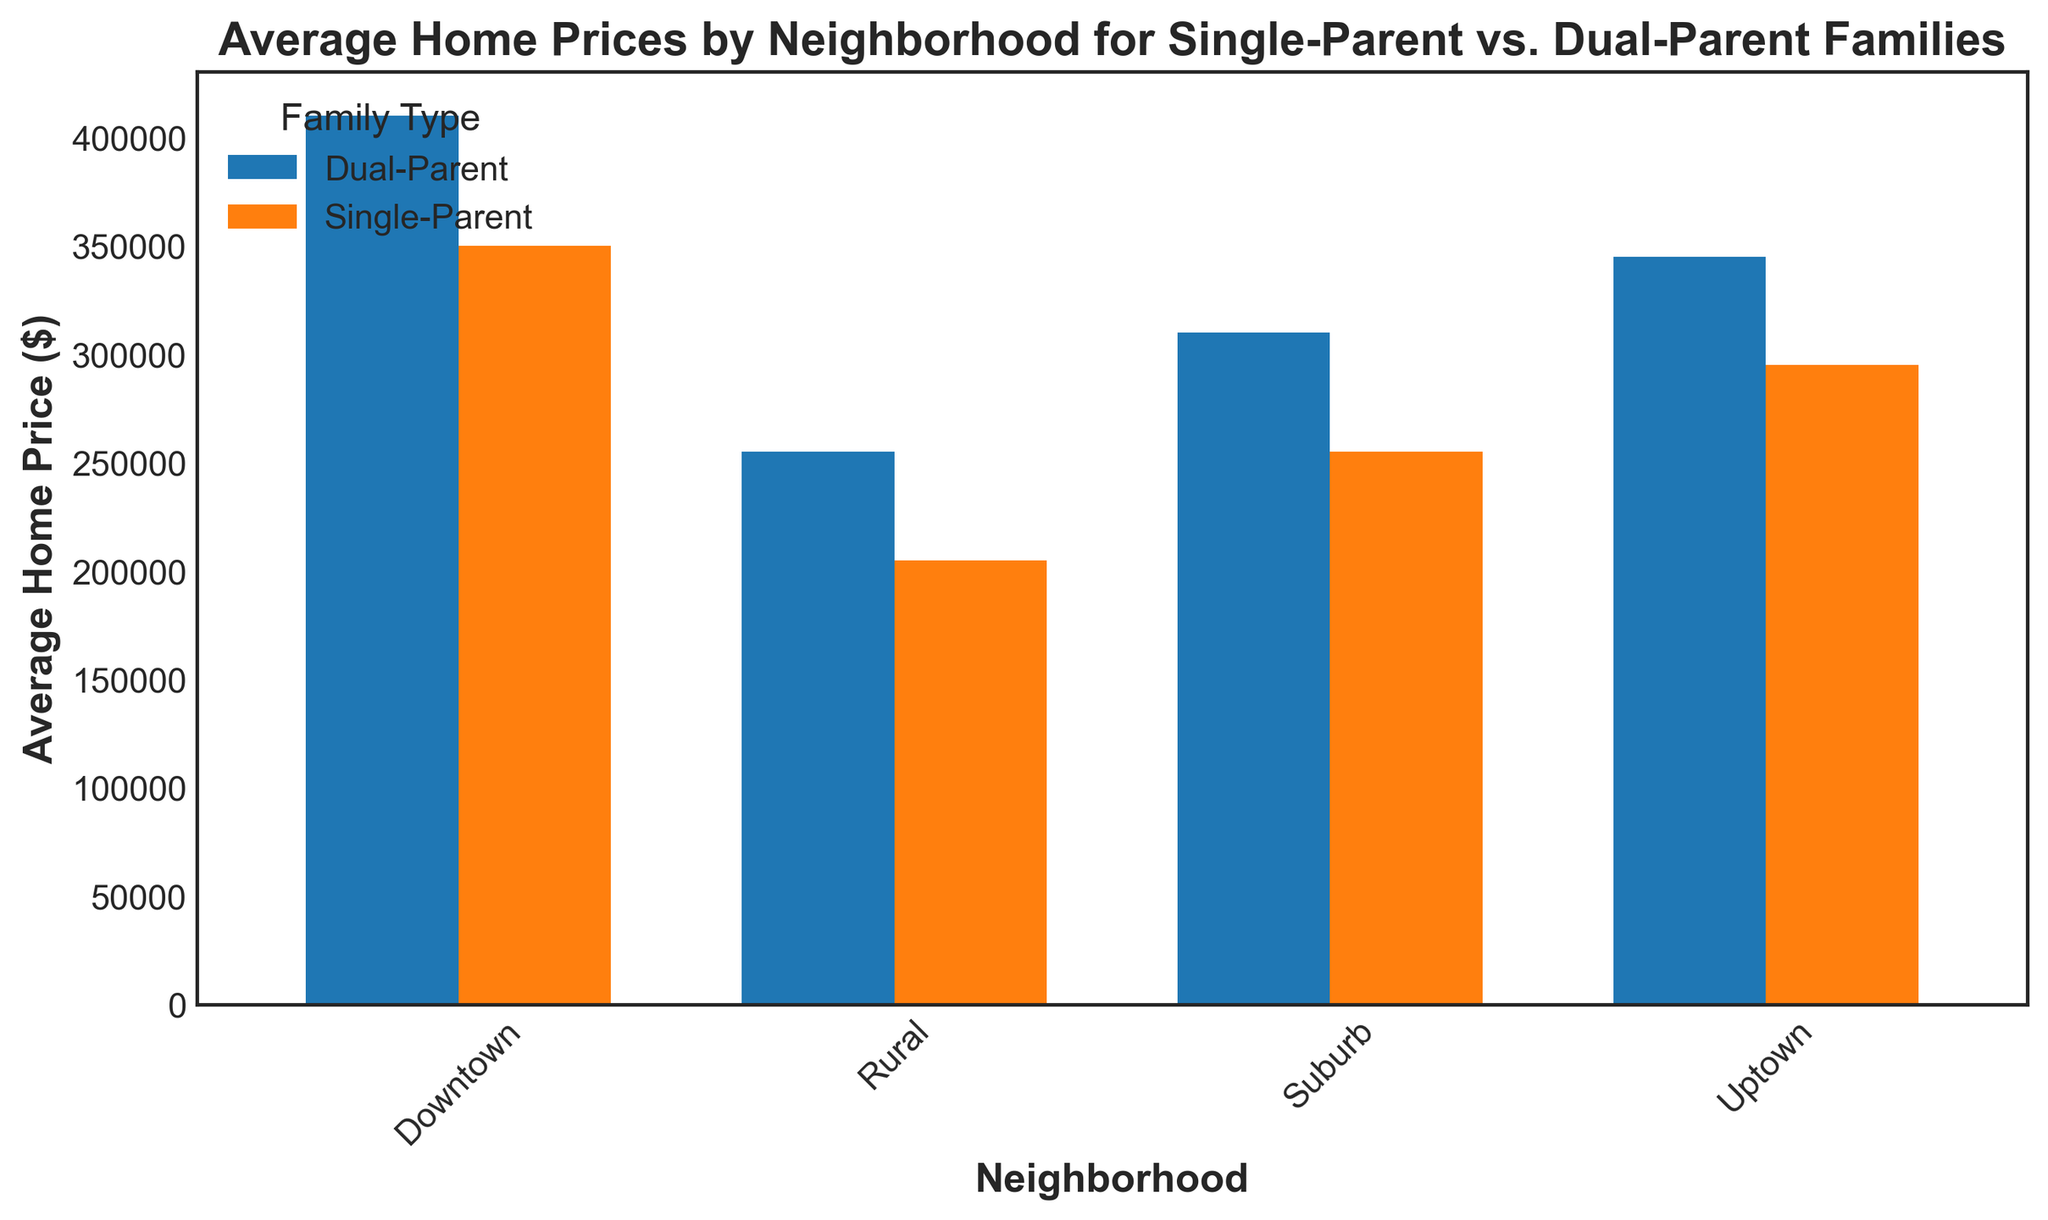What's the average home price for single-parent families in the Downtown neighborhood? Visually, you can observe the bars for single-parent families in the Downtown neighborhood. The average is given by the height of the blue bar representing single-parent families. So the average home price for single-parent families in Downtown is $350,000.
Answer: $350,000 Which neighborhood has the highest average home price for dual-parent families? Examine the orange bars across all neighborhoods, which represent the average home prices for dual-parent families. Identify the tallest orange bar. It is in the Downtown neighborhood.
Answer: Downtown What is the price difference between single-parent and dual-parent families in the Uptown neighborhood? Look at the blue bar for single-parent families and the orange bar for dual-parent families in the Uptown neighborhood. The blue bar (single-parent) is at $295,000, and the orange bar (dual-parent) is at $345,000. The difference is $345,000 - $295,000 = $50,000.
Answer: $50,000 Which family type has a higher average home price in the Suburb neighborhood? Compare the heights of the blue and orange bars for the Suburb neighborhood. The orange bar representing dual-parent families is higher than the blue bar representing single-parent families.
Answer: Dual-Parent Families What's the average home price for dual-parent families in the Rural neighborhood? Look at the orange bar for dual-parent families in the Rural neighborhood. The height of the orange bar gives the average home price, which is $255,000.
Answer: $255,000 In which neighborhood is the average home price for single-parent families the highest? Examine all the blue bars representing single-parent families across neighborhoods. The highest blue bar is in the Downtown neighborhood, indicating the highest average home price for single-parent families.
Answer: Downtown What is the total average home price for all family types in the Downtown neighborhood? Sum the average home prices for single-parent ($350,000) and dual-parent ($410,000) families in the Downtown neighborhood. The total is $350,000 + $410,000 = $760,000.
Answer: $760,000 How much less is the average home price for single-parent families compared to dual-parent families in the Downtown neighborhood? Identify the average prices for both family types in the Downtown neighborhood. The average for single-parent is $350,000 and for dual-parent is $410,000. The difference is $410,000 - $350,000 = $60,000.
Answer: $60,000 Which neighborhood has the smallest difference in average home prices between single-parent and dual-parent families? Calculate or visually compare the differences in each neighborhood. The smallest difference visually appears in the Rural neighborhood, where both bars are closest in height.
Answer: Rural 